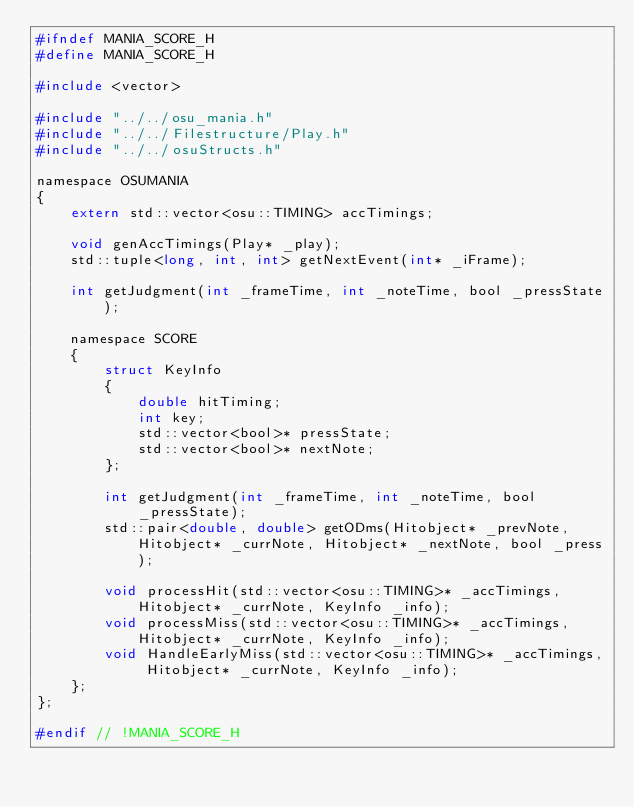<code> <loc_0><loc_0><loc_500><loc_500><_C_>#ifndef MANIA_SCORE_H
#define MANIA_SCORE_H

#include <vector>

#include "../../osu_mania.h"
#include "../../Filestructure/Play.h"
#include "../../osuStructs.h"

namespace OSUMANIA
{
	extern std::vector<osu::TIMING> accTimings;

	void genAccTimings(Play* _play);
	std::tuple<long, int, int> getNextEvent(int* _iFrame);

	int getJudgment(int _frameTime, int _noteTime, bool _pressState);

	namespace SCORE
	{
		struct KeyInfo
		{
			double hitTiming;
			int key;
			std::vector<bool>* pressState;
			std::vector<bool>* nextNote;
		};

		int getJudgment(int _frameTime, int _noteTime, bool _pressState);
		std::pair<double, double> getODms(Hitobject* _prevNote, Hitobject* _currNote, Hitobject* _nextNote, bool _press);

		void processHit(std::vector<osu::TIMING>* _accTimings, Hitobject* _currNote, KeyInfo _info);
		void processMiss(std::vector<osu::TIMING>* _accTimings, Hitobject* _currNote, KeyInfo _info);
		void HandleEarlyMiss(std::vector<osu::TIMING>* _accTimings, Hitobject* _currNote, KeyInfo _info);
	};
};

#endif // !MANIA_SCORE_H</code> 